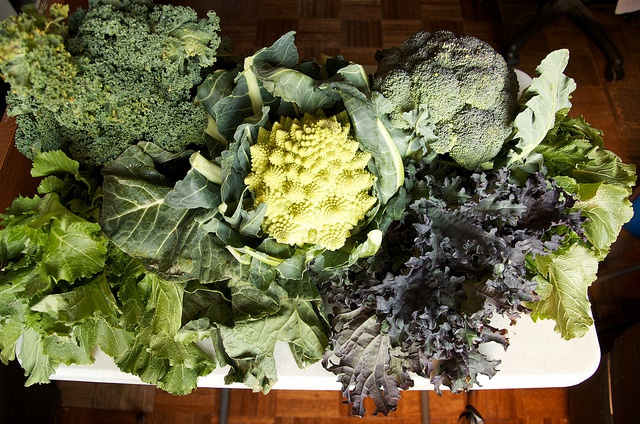Describe the objects in this image and their specific colors. I can see dining table in gray, ivory, black, and olive tones, broccoli in gray, black, darkgreen, and olive tones, and broccoli in gray, black, darkgray, and beige tones in this image. 